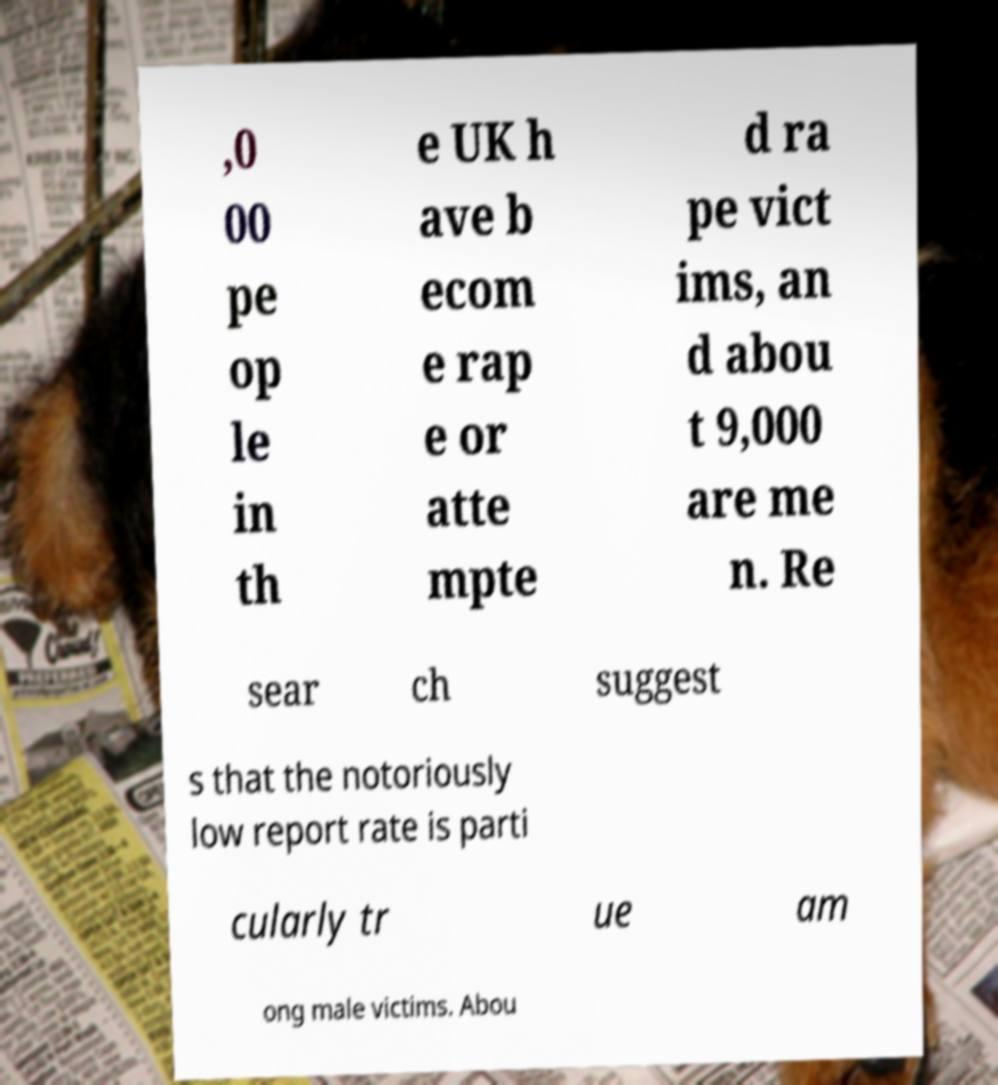I need the written content from this picture converted into text. Can you do that? ,0 00 pe op le in th e UK h ave b ecom e rap e or atte mpte d ra pe vict ims, an d abou t 9,000 are me n. Re sear ch suggest s that the notoriously low report rate is parti cularly tr ue am ong male victims. Abou 